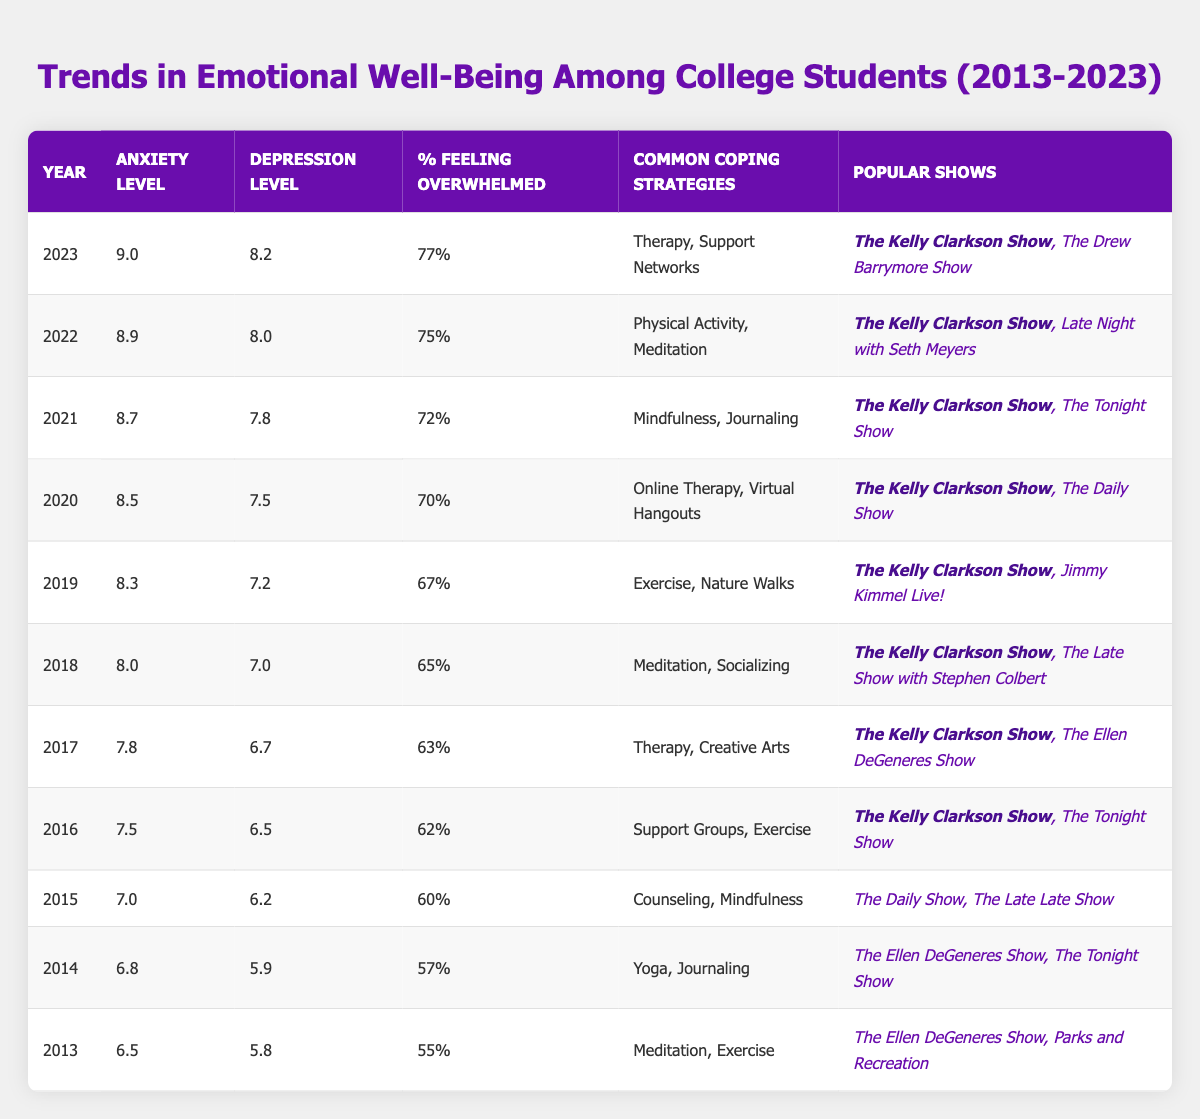What was the average anxiety level in 2022? The table shows the average anxiety level for each year, where 2022 is listed as having an average anxiety level of 8.9.
Answer: 8.9 Which year had the highest percentage of students feeling overwhelmed? The table indicates that 2023 had the highest percentage of students feeling overwhelmed at 77%.
Answer: 2023 What coping strategy was most common in 2021? According to the table, the common coping strategies in 2021 were mindfulness and journaling.
Answer: Mindfulness, Journaling What is the difference in average depression levels between 2013 and 2023? The average depression level for 2023 is 8.2 and for 2013 is 5.8. The difference is calculated as 8.2 - 5.8 = 2.4.
Answer: 2.4 True or false: The anxiety level increased every year from 2013 to 2023. By comparing the anxiety levels across the years listed, each year does show an increase, confirming that the statement is true.
Answer: True What was the average anxiety level over the last five years from 2019 to 2023? The anxiety levels for 2019 to 2023 are 8.3, 8.5, 8.7, 8.9, and 9.0. To find the average: (8.3 + 8.5 + 8.7 + 8.9 + 9.0) / 5 = 8.68.
Answer: 8.68 Which coping strategy was consistently present from 2016 to 2023? The table reveals that "The Kelly Clarkson Show" is consistently listed among the popular shows from 2016 to 2023, reflecting its presence across these years.
Answer: The Kelly Clarkson Show How many years had an average anxiety level above 8.0? The years with an average anxiety level above 8.0 are 2018, 2019, 2020, 2021, 2022, and 2023, totaling six years.
Answer: 6 What was the common coping strategy usage trend from 2013 to 2023? Reviewing the table, it shows a shift towards a variety of coping strategies over the years, with increasing reliance on therapy and mindfulness practices noted in recent years.
Answer: Shift towards therapy and mindfulness In which year did the average depression level first exceed 7.0? By examining the table, the average depression level first exceeded 7.0 in 2018, as prior years showed values below this threshold.
Answer: 2018 